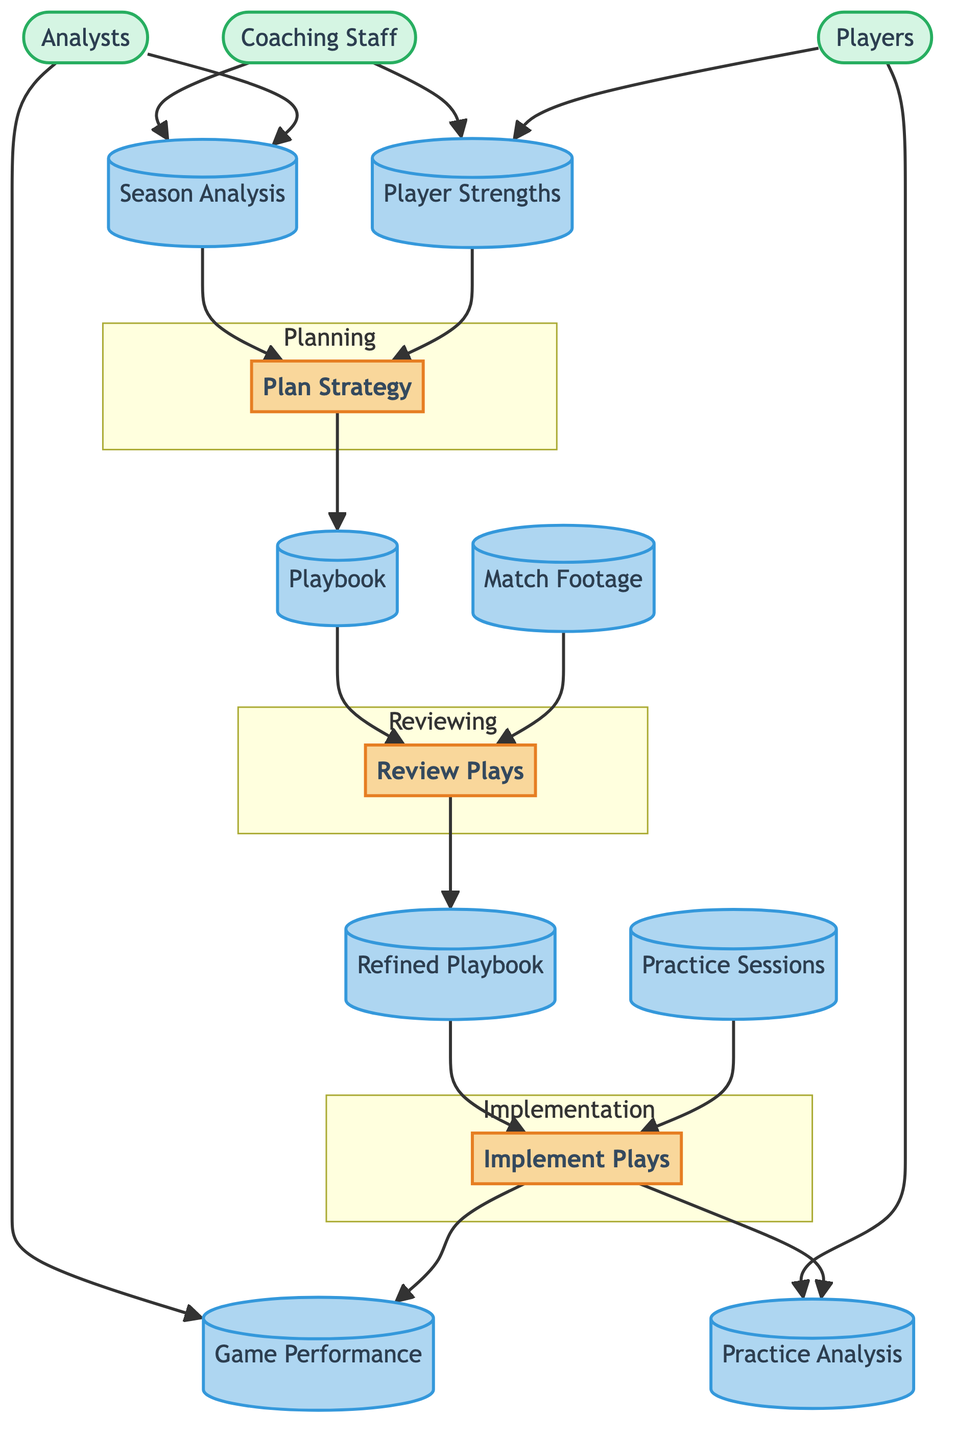What is the first process in the diagram? The first process in the diagram is identified as "Plan Strategy," which is labeled as the initial step in the flow of actions.
Answer: Plan Strategy How many external entities are present in the diagram? The diagram includes three external entities, namely "Coaching Staff," "Players," and "Analysts," which are represented separately.
Answer: 3 What is the output of the "Implement Plays" process? The "Implement Plays" process produces two outputs: "Game Performance" and "Practice Analysis," which can be seen connected to this process in the diagram.
Answer: Game Performance, Practice Analysis Which process uses the "Playbook" as an input? The "Review Plays" process takes in the "Playbook" as an input, which means this process is dependent on the data contained in the playbook.
Answer: Review Plays What kind of data does the "Players" external entity output? The "Players" external entity produces outputs which include "Player Strengths" and "Practice Analysis," showing what measurements or evaluations are done by the players.
Answer: Player Strengths, Practice Analysis Which data store is updated by the "Review Plays" process? The "Review Plays" process updates the "Refined Playbook," indicating that it enhances or modifies the playbook based on the reviews conducted.
Answer: Refined Playbook What is the purpose of the "Match Footage" data store in the diagram? The "Match Footage" data store provides video recordings of matches for review, which serve as an essential input for the "Review Plays" process.
Answer: Review Plays How many processes are directly involved in the implementation phase? There is one process labeled "Implement Plays," which is designated as the sole action involved in the implementation phase of the strategy communication.
Answer: 1 What relationship exists between "Season Analysis" and "Plan Strategy"? The relationship is that "Season Analysis" serves as one of the necessary inputs for the "Plan Strategy" process, indicating it influences strategy development.
Answer: Input 